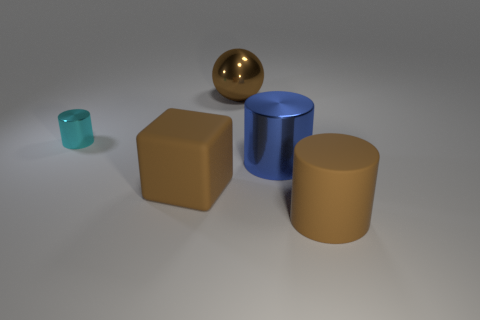Subtract all small cyan metal cylinders. How many cylinders are left? 2 Subtract 0 cyan blocks. How many objects are left? 5 Subtract all cylinders. How many objects are left? 2 Subtract 2 cylinders. How many cylinders are left? 1 Subtract all brown cylinders. Subtract all green blocks. How many cylinders are left? 2 Subtract all gray spheres. How many brown cylinders are left? 1 Subtract all big brown cylinders. Subtract all brown cylinders. How many objects are left? 3 Add 1 big cylinders. How many big cylinders are left? 3 Add 5 cyan things. How many cyan things exist? 6 Add 1 brown balls. How many objects exist? 6 